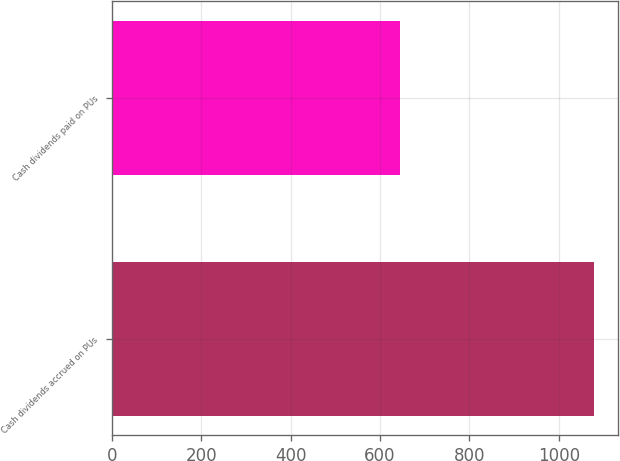<chart> <loc_0><loc_0><loc_500><loc_500><bar_chart><fcel>Cash dividends accrued on PUs<fcel>Cash dividends paid on PUs<nl><fcel>1078<fcel>645<nl></chart> 